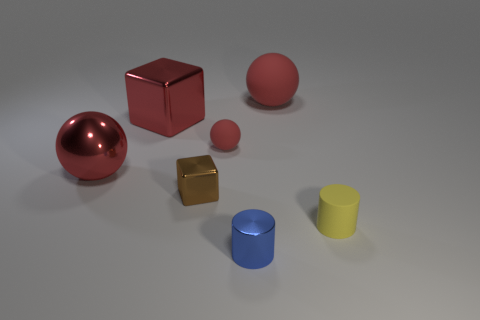Subtract all blue blocks. Subtract all blue cylinders. How many blocks are left? 2 Add 2 big red blocks. How many objects exist? 9 Subtract all blocks. How many objects are left? 5 Add 5 big brown metallic objects. How many big brown metallic objects exist? 5 Subtract 0 gray cubes. How many objects are left? 7 Subtract all yellow cylinders. Subtract all cylinders. How many objects are left? 4 Add 7 large objects. How many large objects are left? 10 